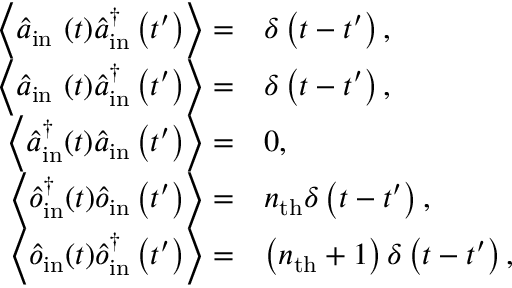<formula> <loc_0><loc_0><loc_500><loc_500>\begin{array} { r l } { \left \langle \hat { a } _ { i n } ( t ) \hat { a } _ { i n } ^ { \dagger } \left ( t ^ { \prime } \right ) \right \rangle = } & { \delta \left ( t - t ^ { \prime } \right ) , } \\ { \left \langle \hat { a } _ { i n } ( t ) \hat { a } _ { i n } ^ { \dagger } \left ( t ^ { \prime } \right ) \right \rangle = } & { \delta \left ( t - t ^ { \prime } \right ) , } \\ { \left \langle \hat { a } _ { i n } ^ { \dagger } ( t ) \hat { a } _ { i n } \left ( t ^ { \prime } \right ) \right \rangle = } & { 0 , } \\ { \left \langle \hat { o } _ { i n } ^ { \dagger } ( t ) \hat { o } _ { i n } \left ( t ^ { \prime } \right ) \right \rangle = } & { n _ { t h } \delta \left ( t - t ^ { \prime } \right ) , } \\ { \left \langle \hat { o } _ { i n } ( t ) \hat { o } _ { i n } ^ { \dagger } \left ( t ^ { \prime } \right ) \right \rangle = } & { \left ( n _ { t h } + 1 \right ) \delta \left ( t - t ^ { \prime } \right ) , } \end{array}</formula> 